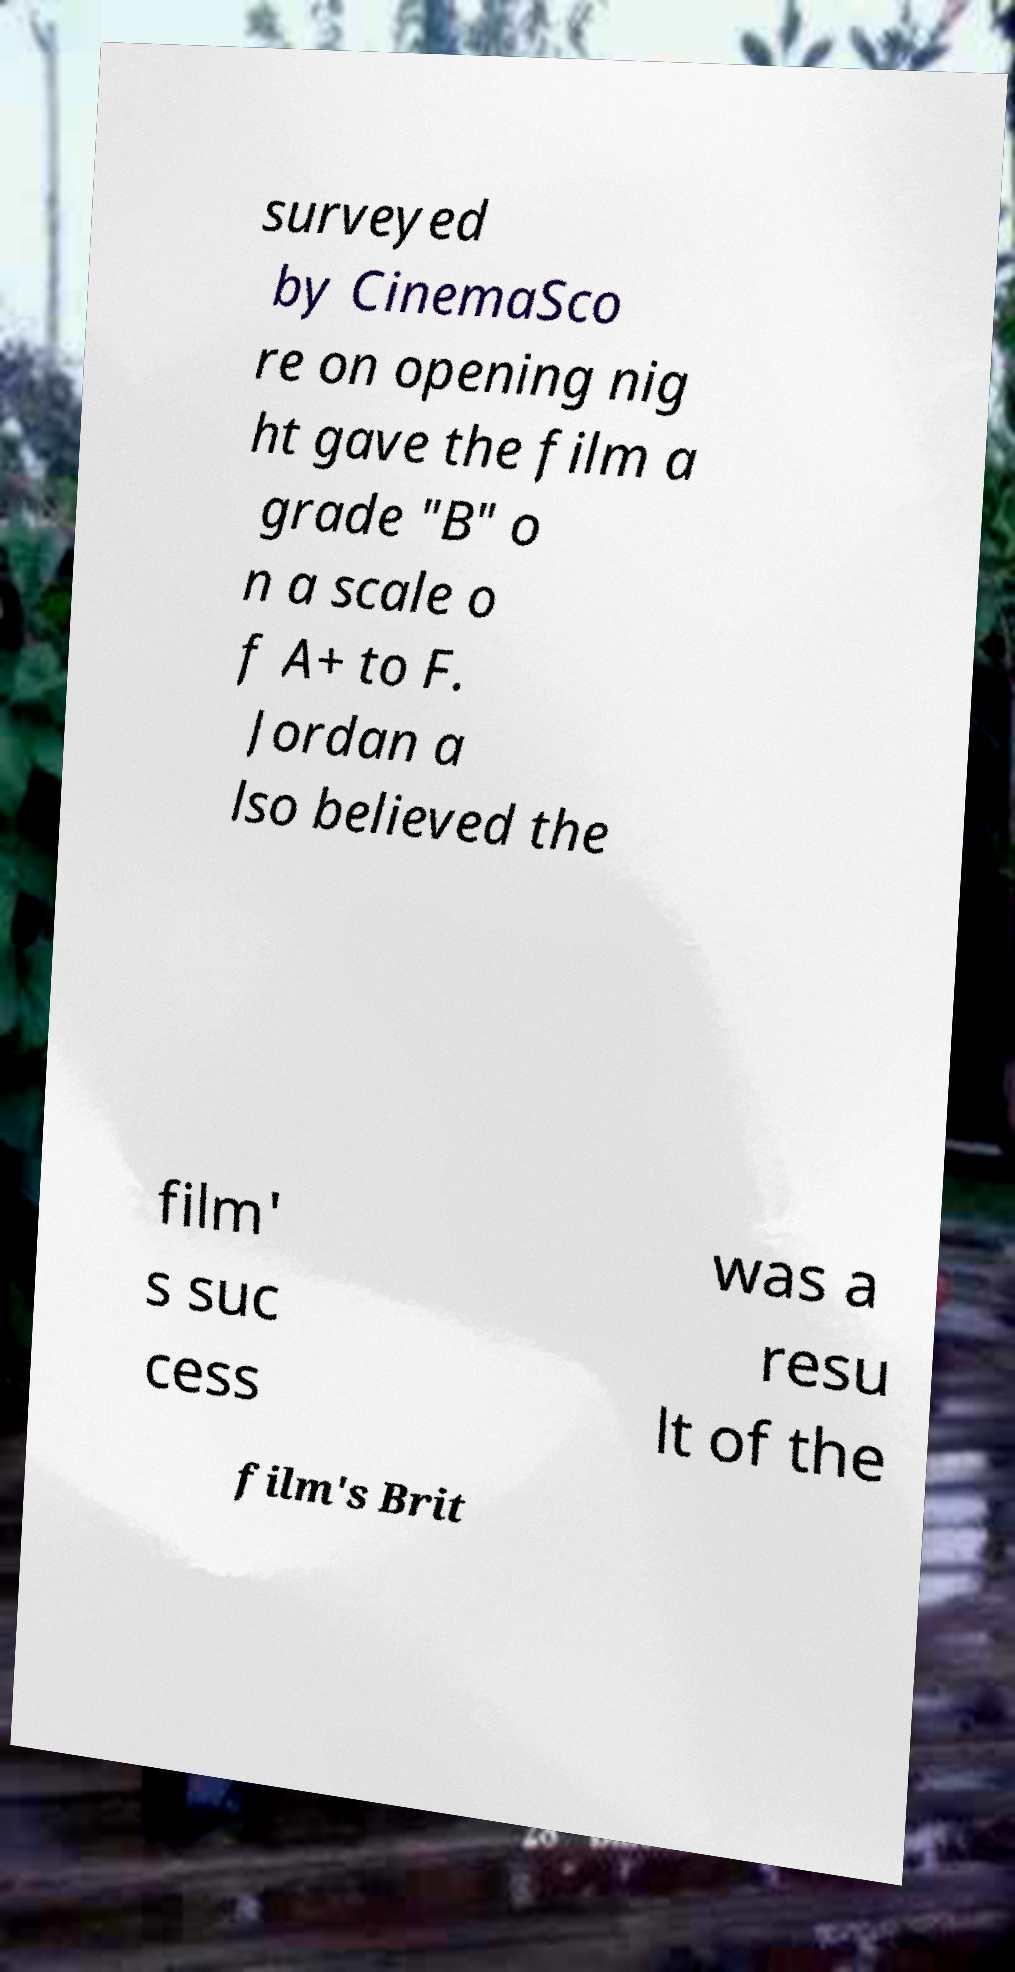I need the written content from this picture converted into text. Can you do that? surveyed by CinemaSco re on opening nig ht gave the film a grade "B" o n a scale o f A+ to F. Jordan a lso believed the film' s suc cess was a resu lt of the film's Brit 